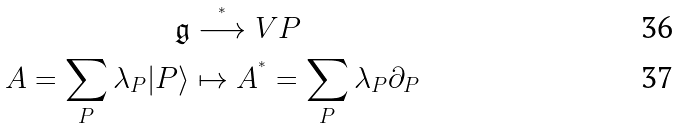Convert formula to latex. <formula><loc_0><loc_0><loc_500><loc_500>\mathfrak { g } & \stackrel { ^ { * } } { \longrightarrow } V P \\ A = \sum _ { P } \lambda _ { P } | P \rangle & \mapsto A ^ { ^ { * } } = \sum _ { P } \lambda _ { P } \partial _ { P }</formula> 